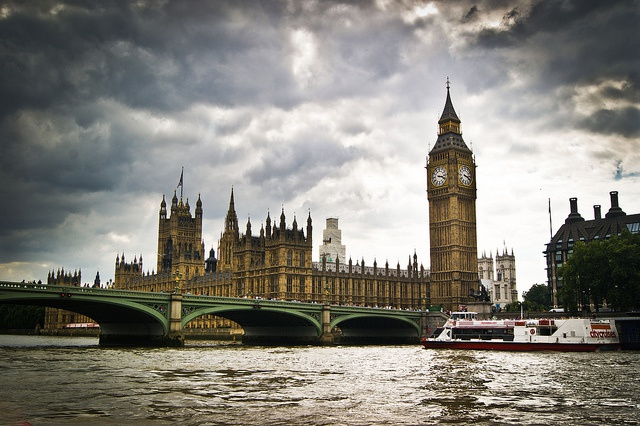Describe the objects in this image and their specific colors. I can see boat in black, lightgray, darkgray, and maroon tones, clock in black, gray, darkgray, and olive tones, and clock in black, gray, darkgray, and lightgray tones in this image. 